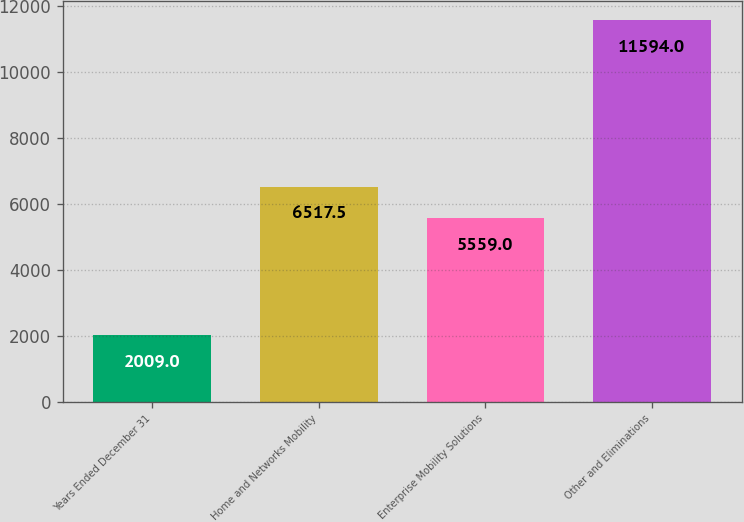<chart> <loc_0><loc_0><loc_500><loc_500><bar_chart><fcel>Years Ended December 31<fcel>Home and Networks Mobility<fcel>Enterprise Mobility Solutions<fcel>Other and Eliminations<nl><fcel>2009<fcel>6517.5<fcel>5559<fcel>11594<nl></chart> 